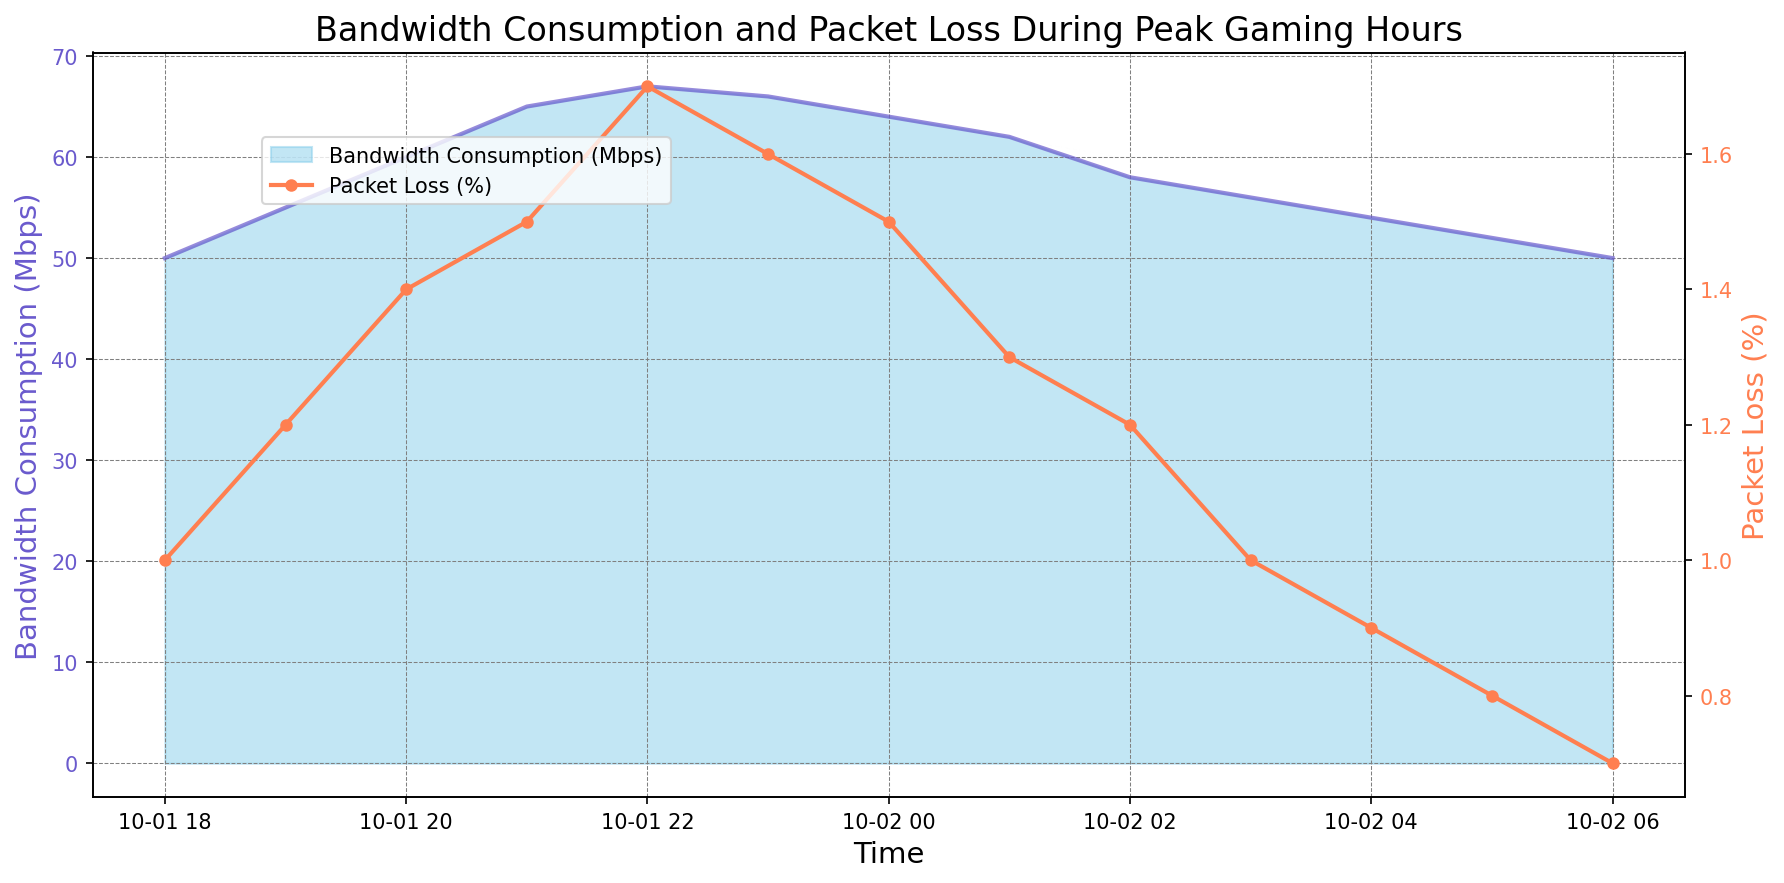Which timestamp shows the highest bandwidth consumption? The highest bandwidth consumption can be visually identified as the peak of the area chart. The peak occurs around 2023-10-01 22:00 with 67 Mbps.
Answer: 2023-10-01 22:00 How does the packet loss percentage change from 18:00 to 23:00 on October 1st? By tracking the red line from 18:00 to 23:00 on October 1st, packet loss percentage goes from 1.0% to a peak of 1.7%, then slightly decreases to 1.6%.
Answer: It increases from 1.0% to 1.7%, then slightly decreases to 1.6% What difference in bandwidth consumption is observed between 20:00 and 02:00? By reading the figure, bandwidth consumption at 20:00 is 60 Mbps and at 02:00 it is 58 Mbps. Subtracting 58 from 60 gives the difference of 2 Mbps.
Answer: 2 Mbps Is packet loss more stable before midnight or after midnight? Visually comparing the smoothness of the red line, packet loss appears more stable after midnight with fewer fluctuations, compared to more noticeable changes before midnight.
Answer: After midnight What is the average bandwidth consumption during the peak gaming hours from 18:00 to 00:00? Calculating the average involves summing bandwidth consumptions at 18:00 to 00:00 and dividing by the number of data points: (50+55+60+65+67+66+64)/7 = 61.
Answer: 61 Mbps By how much does the bandwidth consumption decrease from its peak at 22:00 to 06:00? The peak bandwidth at 22:00 is 67 Mbps and at 06:00 it is 50 Mbps. Subtracting 50 from 67 gives the decrease of 17 Mbps.
Answer: 17 Mbps Compare the packet loss percentages at 21:00 and 01:00. At 21:00, the packet loss percentage is 1.5%, and at 01:00, it is 1.3%. Comparing these, 21:00 has a higher packet loss.
Answer: 21:00 has a higher packet loss What was the bandwidth consumption trend from 18:00 to 23:00 on October 1st? Observing the chart, from 18:00 to 23:00, bandwidth consumption shows a steady upward trend, increasing progressively from 50 Mbps to 66 Mbps.
Answer: Steady upward trend What is the shape of the packet loss trendline on the chart? The packet loss trendline is slightly erratic, going up and down with some peaks around 22:00, before gently decreasing after midnight.
Answer: Slightly erratic, with peaks around 22:00 